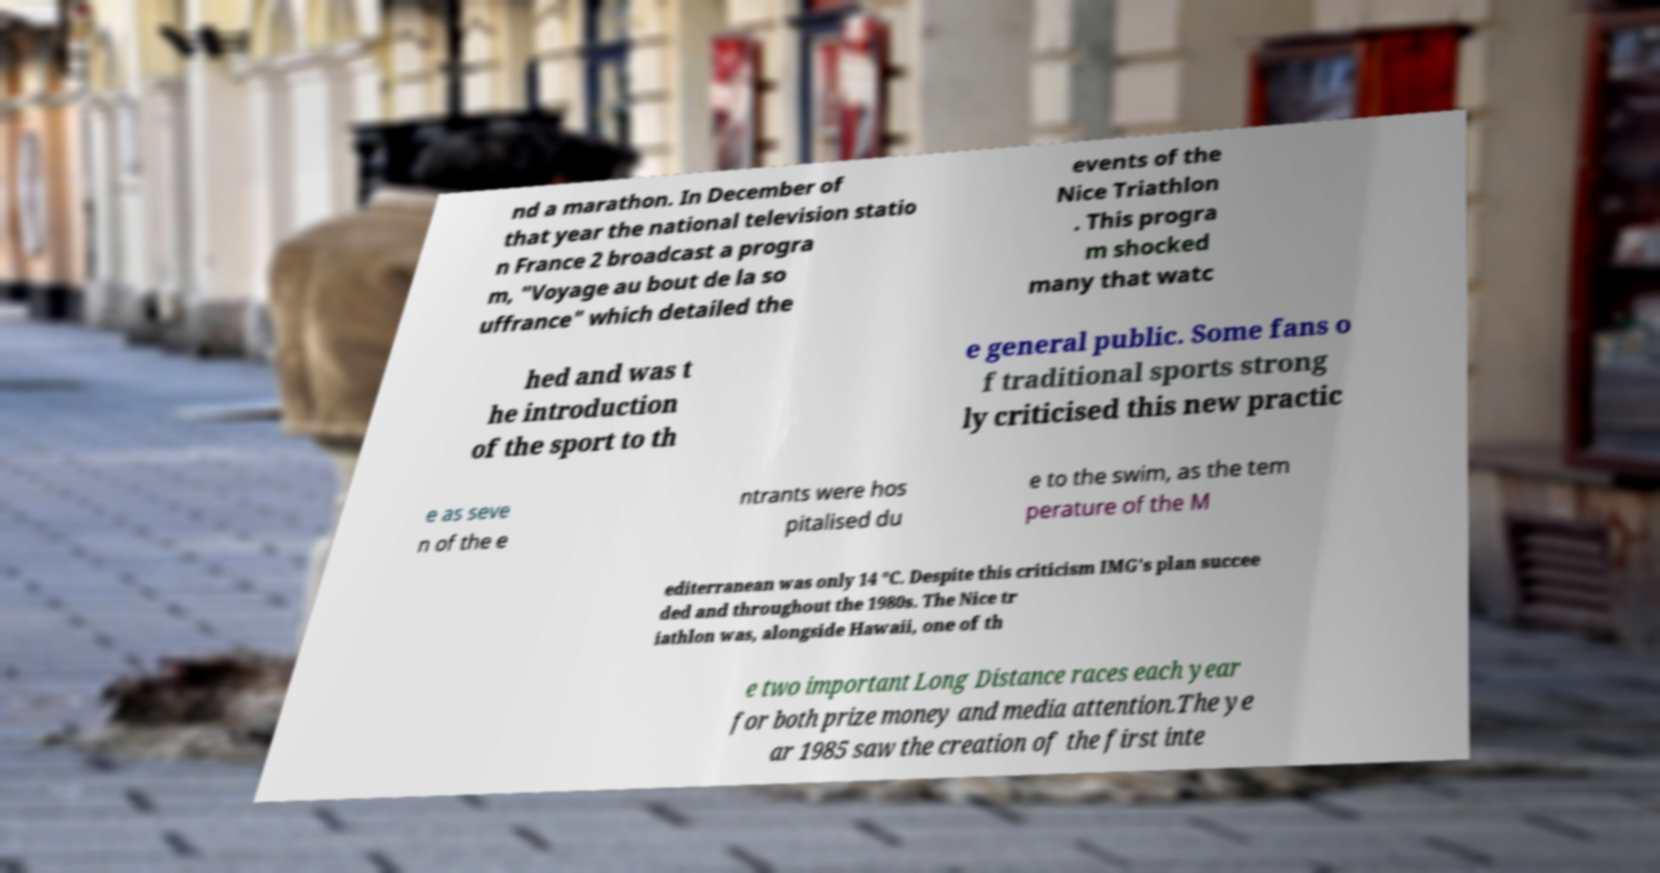What messages or text are displayed in this image? I need them in a readable, typed format. nd a marathon. In December of that year the national television statio n France 2 broadcast a progra m, "Voyage au bout de la so uffrance" which detailed the events of the Nice Triathlon . This progra m shocked many that watc hed and was t he introduction of the sport to th e general public. Some fans o f traditional sports strong ly criticised this new practic e as seve n of the e ntrants were hos pitalised du e to the swim, as the tem perature of the M editerranean was only 14 °C. Despite this criticism IMG's plan succee ded and throughout the 1980s. The Nice tr iathlon was, alongside Hawaii, one of th e two important Long Distance races each year for both prize money and media attention.The ye ar 1985 saw the creation of the first inte 